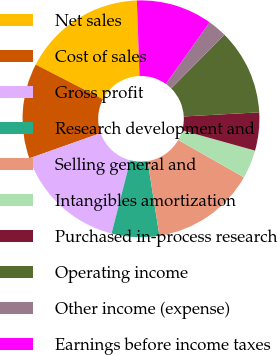Convert chart. <chart><loc_0><loc_0><loc_500><loc_500><pie_chart><fcel>Net sales<fcel>Cost of sales<fcel>Gross profit<fcel>Research development and<fcel>Selling general and<fcel>Intangibles amortization<fcel>Purchased in-process research<fcel>Operating income<fcel>Other income (expense)<fcel>Earnings before income taxes<nl><fcel>16.88%<fcel>12.99%<fcel>15.58%<fcel>6.49%<fcel>14.28%<fcel>3.9%<fcel>5.2%<fcel>11.69%<fcel>2.6%<fcel>10.39%<nl></chart> 